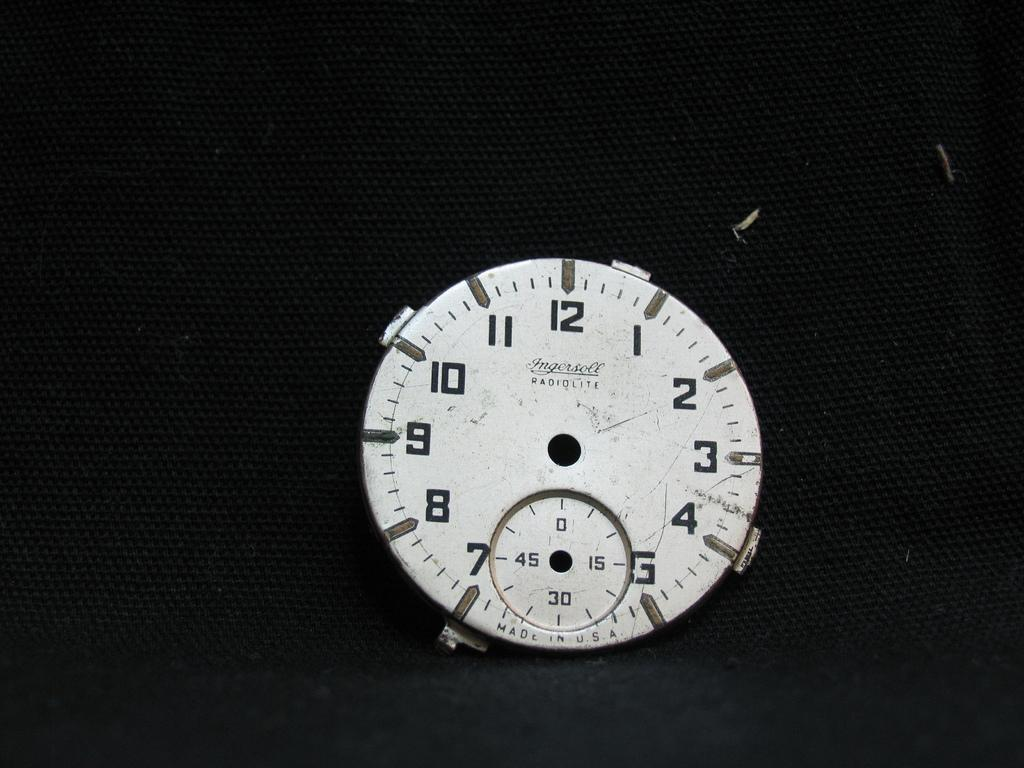<image>
Provide a brief description of the given image. Face of a watch which says Radiolite on it. 